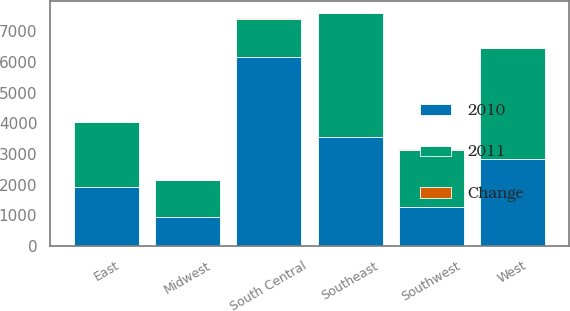Convert chart to OTSL. <chart><loc_0><loc_0><loc_500><loc_500><stacked_bar_chart><ecel><fcel>East<fcel>Midwest<fcel>Southeast<fcel>South Central<fcel>Southwest<fcel>West<nl><fcel>2010<fcel>1932<fcel>964<fcel>3546<fcel>6150<fcel>1263<fcel>2840<nl><fcel>2011<fcel>2114<fcel>1187<fcel>4049<fcel>1263<fcel>1872<fcel>3607<nl><fcel>Change<fcel>9<fcel>19<fcel>12<fcel>24<fcel>33<fcel>21<nl></chart> 